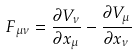<formula> <loc_0><loc_0><loc_500><loc_500>F _ { \mu \nu } = \frac { \partial V _ { \nu } } { \partial x _ { \mu } } - \frac { \partial V _ { \mu } } { \partial x _ { \nu } }</formula> 